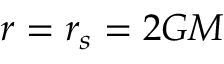<formula> <loc_0><loc_0><loc_500><loc_500>r = r _ { s } = 2 G M</formula> 